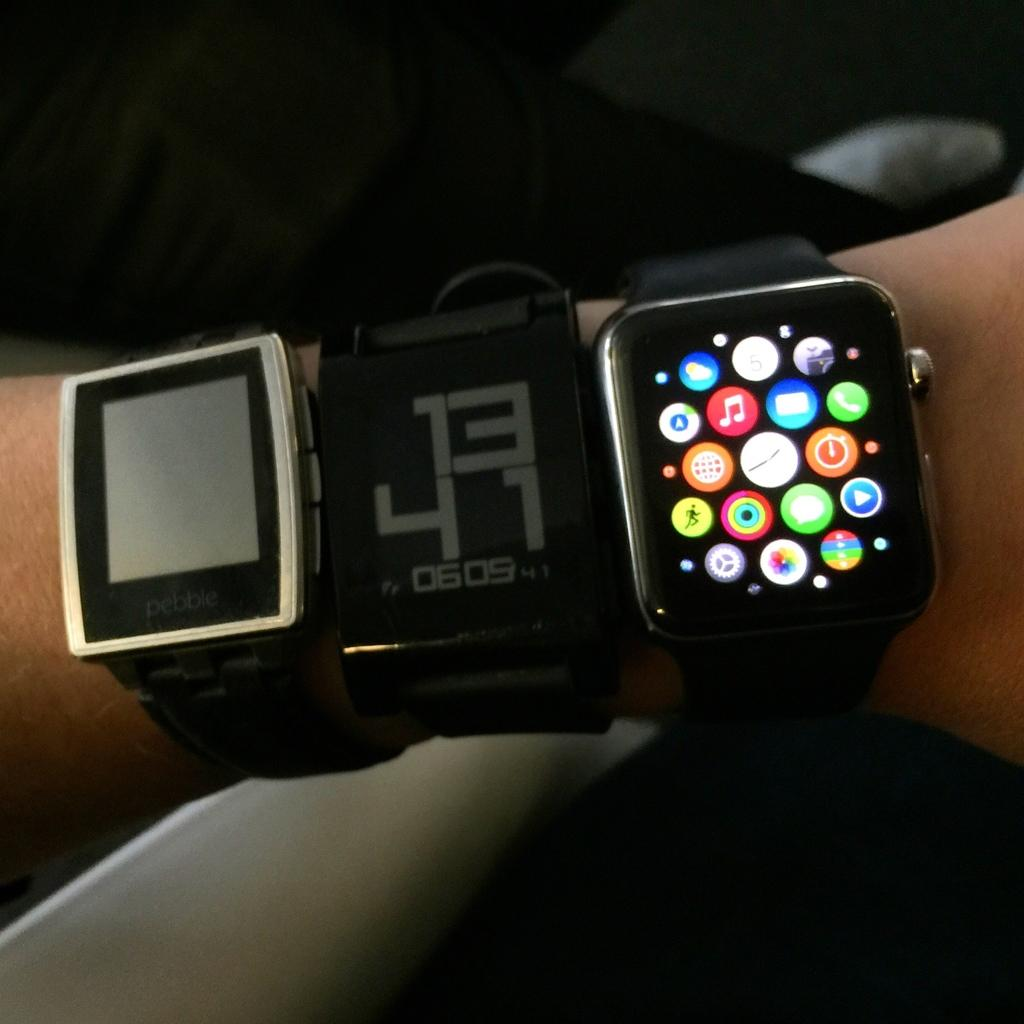Provide a one-sentence caption for the provided image. Person wearing three watches including one that says 1341. 